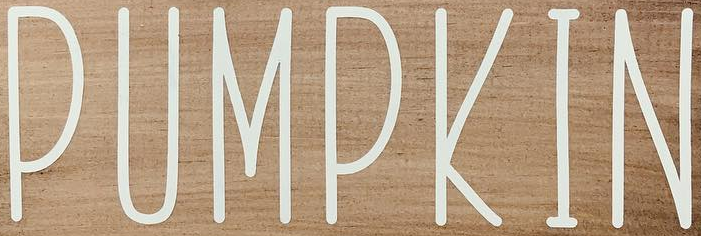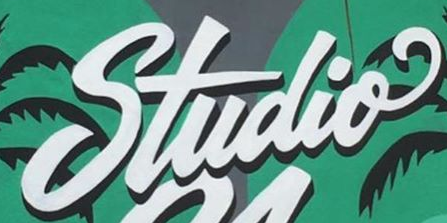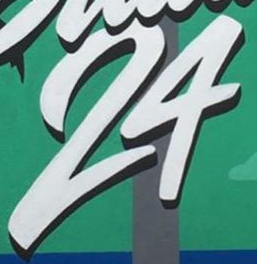What words are shown in these images in order, separated by a semicolon? PUMPKIN; Studio; 24 